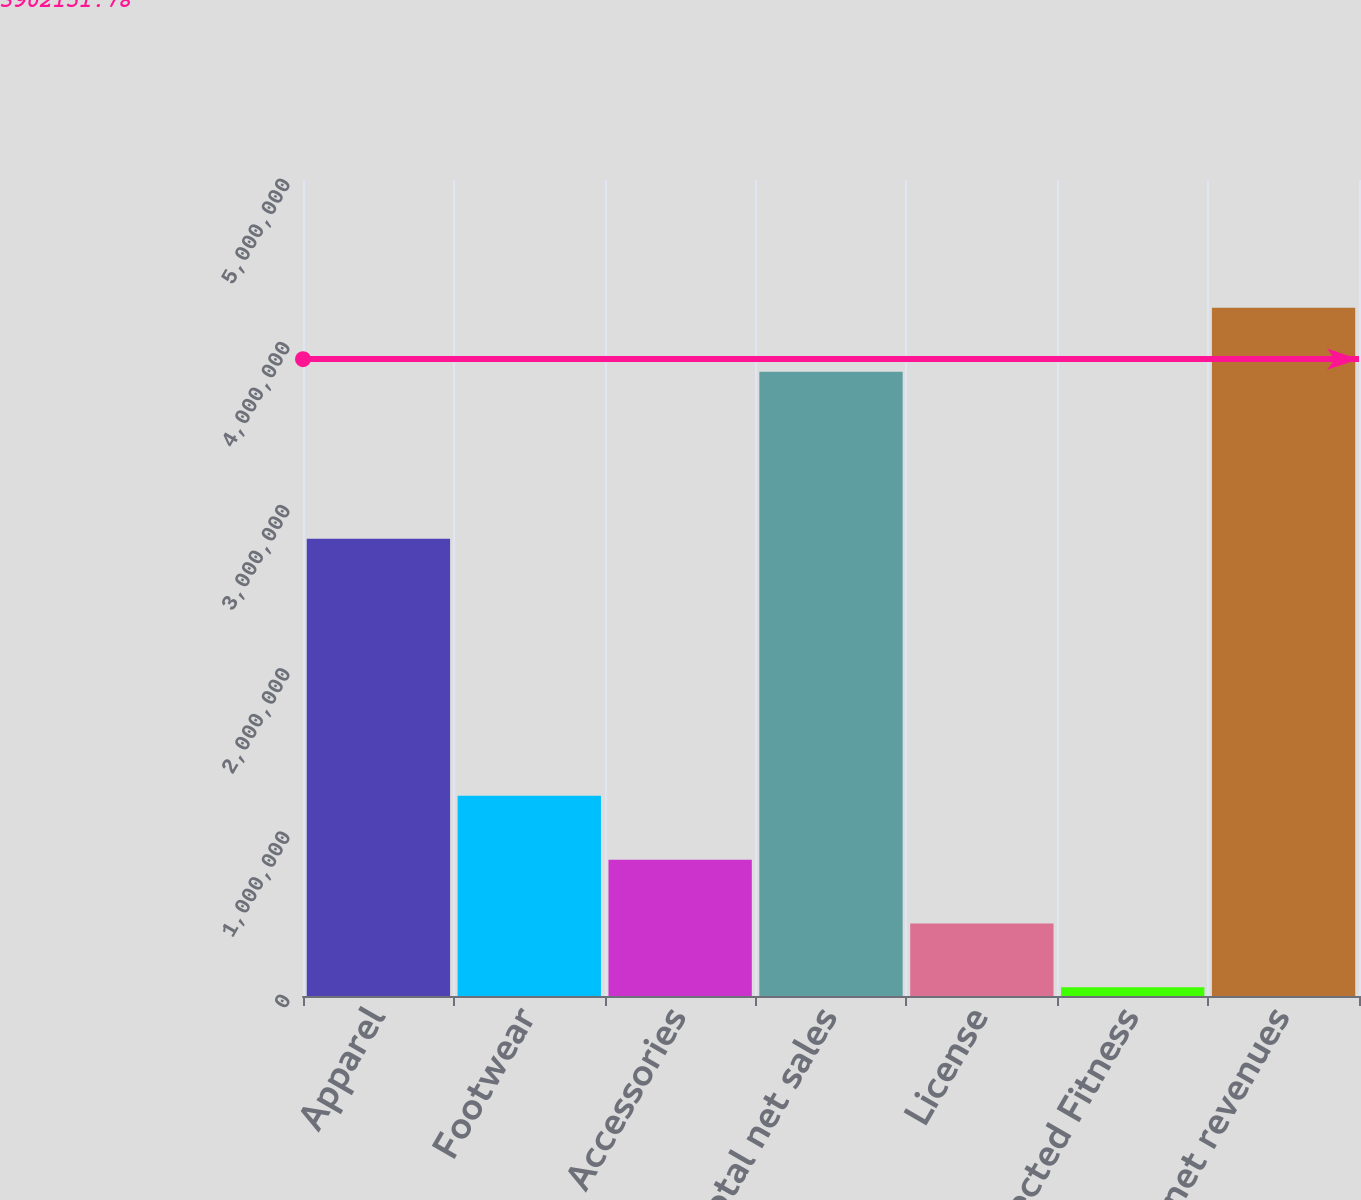<chart> <loc_0><loc_0><loc_500><loc_500><bar_chart><fcel>Apparel<fcel>Footwear<fcel>Accessories<fcel>Total net sales<fcel>License<fcel>Connected Fitness<fcel>Total net revenues<nl><fcel>2.80106e+06<fcel>1.22638e+06<fcel>835395<fcel>3.82569e+06<fcel>444405<fcel>53415<fcel>4.21668e+06<nl></chart> 